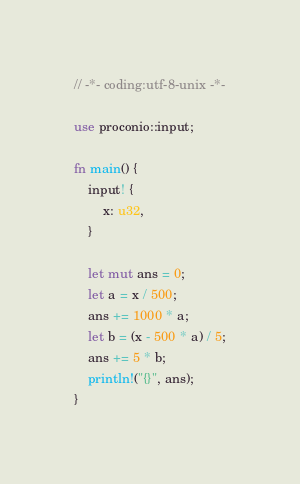Convert code to text. <code><loc_0><loc_0><loc_500><loc_500><_Rust_>// -*- coding:utf-8-unix -*-

use proconio::input;

fn main() {
    input! {
        x: u32,
    }

    let mut ans = 0;
    let a = x / 500;
    ans += 1000 * a;
    let b = (x - 500 * a) / 5;
    ans += 5 * b;
    println!("{}", ans);
}
</code> 